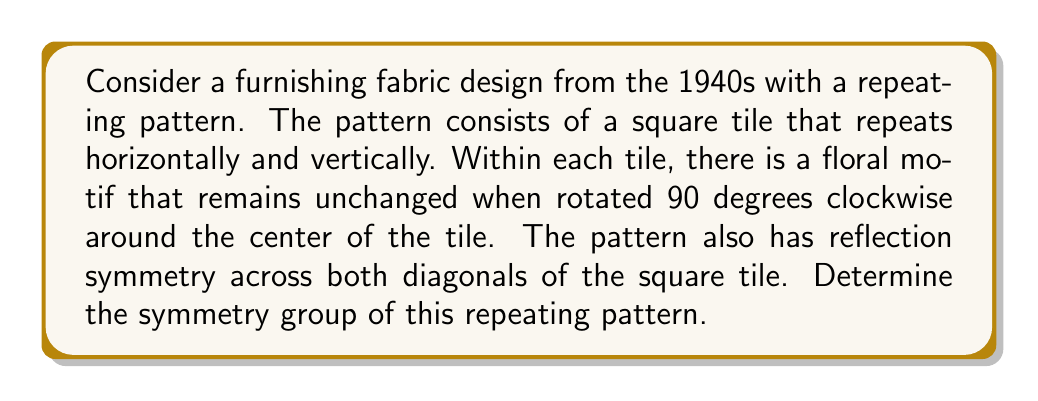Give your solution to this math problem. To determine the symmetry group of this repeating pattern, we need to identify all the symmetry operations that leave the pattern unchanged. Let's analyze the given information step by step:

1. Translational symmetry:
   The pattern repeats horizontally and vertically, so we have translational symmetry in two directions. Let's denote these as $T_x$ and $T_y$.

2. Rotational symmetry:
   The floral motif within each tile remains unchanged when rotated 90 degrees clockwise. This implies 4-fold rotational symmetry (rotation by 90°, 180°, 270°, and 360°). Let's denote these rotations as $R_{90}$, $R_{180}$, $R_{270}$, and $R_{360}$ (or $E$ for identity).

3. Reflection symmetry:
   The pattern has reflection symmetry across both diagonals of the square tile. Let's denote these reflections as $M_d$ (main diagonal) and $M_a$ (anti-diagonal).

4. Additional symmetries:
   Due to the combination of 4-fold rotation and diagonal reflections, we can deduce that the pattern also has reflection symmetry across the horizontal and vertical axes. Let's denote these as $M_h$ and $M_v$.

The symmetry group of this pattern includes all these operations and their combinations. This group is known as the wallpaper group p4mm, which is one of the 17 two-dimensional crystallographic groups.

The p4mm group has the following properties:
- 4-fold rotational symmetry
- Reflection symmetry in four directions (horizontal, vertical, and two diagonals)
- Translational symmetry in two perpendicular directions

The order of this group is infinite due to the translational symmetries, but if we consider only the symmetries within a single tile, we have 8 elements:
$\{E, R_{90}, R_{180}, R_{270}, M_h, M_v, M_d, M_a\}$

This finite subgroup (ignoring translations) is isomorphic to the dihedral group $D_4$.
Answer: p4mm (wallpaper group) 